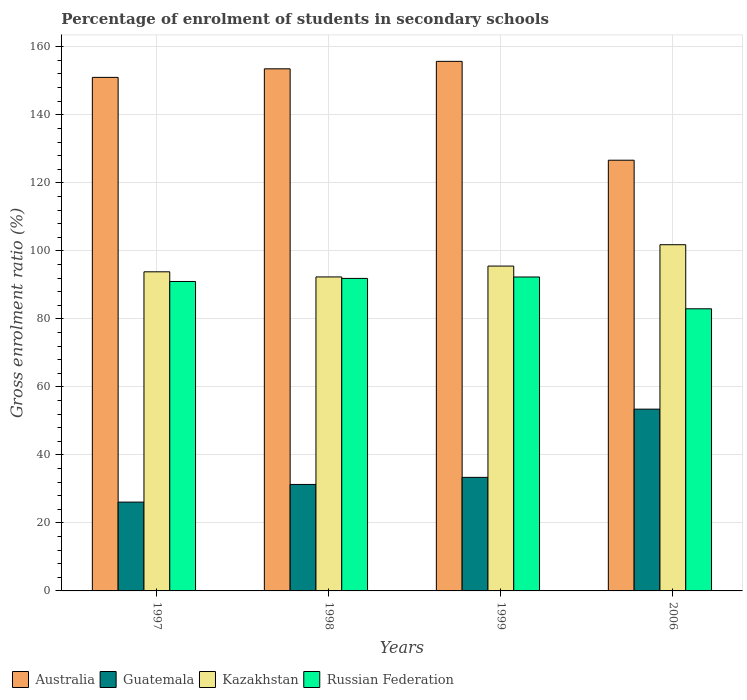Are the number of bars per tick equal to the number of legend labels?
Provide a short and direct response. Yes. Are the number of bars on each tick of the X-axis equal?
Keep it short and to the point. Yes. In how many cases, is the number of bars for a given year not equal to the number of legend labels?
Provide a succinct answer. 0. What is the percentage of students enrolled in secondary schools in Australia in 1997?
Offer a terse response. 151. Across all years, what is the maximum percentage of students enrolled in secondary schools in Kazakhstan?
Offer a terse response. 101.8. Across all years, what is the minimum percentage of students enrolled in secondary schools in Australia?
Your answer should be compact. 126.65. In which year was the percentage of students enrolled in secondary schools in Kazakhstan maximum?
Keep it short and to the point. 2006. What is the total percentage of students enrolled in secondary schools in Kazakhstan in the graph?
Provide a succinct answer. 383.48. What is the difference between the percentage of students enrolled in secondary schools in Guatemala in 1997 and that in 1999?
Make the answer very short. -7.27. What is the difference between the percentage of students enrolled in secondary schools in Australia in 1998 and the percentage of students enrolled in secondary schools in Kazakhstan in 2006?
Make the answer very short. 51.72. What is the average percentage of students enrolled in secondary schools in Kazakhstan per year?
Provide a succinct answer. 95.87. In the year 1998, what is the difference between the percentage of students enrolled in secondary schools in Kazakhstan and percentage of students enrolled in secondary schools in Russian Federation?
Offer a terse response. 0.44. In how many years, is the percentage of students enrolled in secondary schools in Kazakhstan greater than 136 %?
Make the answer very short. 0. What is the ratio of the percentage of students enrolled in secondary schools in Russian Federation in 1997 to that in 2006?
Your response must be concise. 1.1. Is the percentage of students enrolled in secondary schools in Kazakhstan in 1998 less than that in 1999?
Your answer should be very brief. Yes. Is the difference between the percentage of students enrolled in secondary schools in Kazakhstan in 1997 and 1998 greater than the difference between the percentage of students enrolled in secondary schools in Russian Federation in 1997 and 1998?
Ensure brevity in your answer.  Yes. What is the difference between the highest and the second highest percentage of students enrolled in secondary schools in Russian Federation?
Provide a succinct answer. 0.42. What is the difference between the highest and the lowest percentage of students enrolled in secondary schools in Kazakhstan?
Keep it short and to the point. 9.47. In how many years, is the percentage of students enrolled in secondary schools in Russian Federation greater than the average percentage of students enrolled in secondary schools in Russian Federation taken over all years?
Your response must be concise. 3. Is it the case that in every year, the sum of the percentage of students enrolled in secondary schools in Australia and percentage of students enrolled in secondary schools in Guatemala is greater than the sum of percentage of students enrolled in secondary schools in Kazakhstan and percentage of students enrolled in secondary schools in Russian Federation?
Ensure brevity in your answer.  No. What does the 2nd bar from the left in 2006 represents?
Provide a succinct answer. Guatemala. What does the 4th bar from the right in 1997 represents?
Give a very brief answer. Australia. How many years are there in the graph?
Give a very brief answer. 4. Are the values on the major ticks of Y-axis written in scientific E-notation?
Provide a short and direct response. No. Where does the legend appear in the graph?
Make the answer very short. Bottom left. How many legend labels are there?
Ensure brevity in your answer.  4. What is the title of the graph?
Your answer should be compact. Percentage of enrolment of students in secondary schools. Does "South Africa" appear as one of the legend labels in the graph?
Make the answer very short. No. What is the label or title of the Y-axis?
Offer a very short reply. Gross enrolment ratio (%). What is the Gross enrolment ratio (%) in Australia in 1997?
Offer a terse response. 151. What is the Gross enrolment ratio (%) in Guatemala in 1997?
Your answer should be compact. 26.12. What is the Gross enrolment ratio (%) in Kazakhstan in 1997?
Your answer should be very brief. 93.83. What is the Gross enrolment ratio (%) in Russian Federation in 1997?
Offer a terse response. 90.99. What is the Gross enrolment ratio (%) of Australia in 1998?
Keep it short and to the point. 153.52. What is the Gross enrolment ratio (%) of Guatemala in 1998?
Give a very brief answer. 31.31. What is the Gross enrolment ratio (%) of Kazakhstan in 1998?
Make the answer very short. 92.33. What is the Gross enrolment ratio (%) of Russian Federation in 1998?
Offer a terse response. 91.89. What is the Gross enrolment ratio (%) of Australia in 1999?
Offer a terse response. 155.71. What is the Gross enrolment ratio (%) of Guatemala in 1999?
Ensure brevity in your answer.  33.39. What is the Gross enrolment ratio (%) in Kazakhstan in 1999?
Offer a very short reply. 95.52. What is the Gross enrolment ratio (%) in Russian Federation in 1999?
Provide a succinct answer. 92.31. What is the Gross enrolment ratio (%) in Australia in 2006?
Your answer should be very brief. 126.65. What is the Gross enrolment ratio (%) of Guatemala in 2006?
Your answer should be compact. 53.45. What is the Gross enrolment ratio (%) of Kazakhstan in 2006?
Give a very brief answer. 101.8. What is the Gross enrolment ratio (%) in Russian Federation in 2006?
Provide a succinct answer. 82.96. Across all years, what is the maximum Gross enrolment ratio (%) of Australia?
Your answer should be compact. 155.71. Across all years, what is the maximum Gross enrolment ratio (%) in Guatemala?
Provide a succinct answer. 53.45. Across all years, what is the maximum Gross enrolment ratio (%) in Kazakhstan?
Your response must be concise. 101.8. Across all years, what is the maximum Gross enrolment ratio (%) of Russian Federation?
Provide a short and direct response. 92.31. Across all years, what is the minimum Gross enrolment ratio (%) in Australia?
Provide a succinct answer. 126.65. Across all years, what is the minimum Gross enrolment ratio (%) in Guatemala?
Give a very brief answer. 26.12. Across all years, what is the minimum Gross enrolment ratio (%) of Kazakhstan?
Make the answer very short. 92.33. Across all years, what is the minimum Gross enrolment ratio (%) of Russian Federation?
Your answer should be compact. 82.96. What is the total Gross enrolment ratio (%) in Australia in the graph?
Your answer should be very brief. 586.88. What is the total Gross enrolment ratio (%) in Guatemala in the graph?
Your answer should be very brief. 144.27. What is the total Gross enrolment ratio (%) in Kazakhstan in the graph?
Your answer should be compact. 383.48. What is the total Gross enrolment ratio (%) of Russian Federation in the graph?
Keep it short and to the point. 358.15. What is the difference between the Gross enrolment ratio (%) of Australia in 1997 and that in 1998?
Ensure brevity in your answer.  -2.52. What is the difference between the Gross enrolment ratio (%) in Guatemala in 1997 and that in 1998?
Your response must be concise. -5.19. What is the difference between the Gross enrolment ratio (%) of Kazakhstan in 1997 and that in 1998?
Your answer should be compact. 1.51. What is the difference between the Gross enrolment ratio (%) of Russian Federation in 1997 and that in 1998?
Offer a terse response. -0.9. What is the difference between the Gross enrolment ratio (%) of Australia in 1997 and that in 1999?
Give a very brief answer. -4.71. What is the difference between the Gross enrolment ratio (%) of Guatemala in 1997 and that in 1999?
Your answer should be compact. -7.27. What is the difference between the Gross enrolment ratio (%) in Kazakhstan in 1997 and that in 1999?
Provide a short and direct response. -1.69. What is the difference between the Gross enrolment ratio (%) in Russian Federation in 1997 and that in 1999?
Make the answer very short. -1.32. What is the difference between the Gross enrolment ratio (%) of Australia in 1997 and that in 2006?
Offer a very short reply. 24.35. What is the difference between the Gross enrolment ratio (%) of Guatemala in 1997 and that in 2006?
Offer a very short reply. -27.33. What is the difference between the Gross enrolment ratio (%) of Kazakhstan in 1997 and that in 2006?
Offer a very short reply. -7.96. What is the difference between the Gross enrolment ratio (%) of Russian Federation in 1997 and that in 2006?
Make the answer very short. 8.03. What is the difference between the Gross enrolment ratio (%) of Australia in 1998 and that in 1999?
Give a very brief answer. -2.19. What is the difference between the Gross enrolment ratio (%) of Guatemala in 1998 and that in 1999?
Your answer should be very brief. -2.08. What is the difference between the Gross enrolment ratio (%) in Kazakhstan in 1998 and that in 1999?
Your response must be concise. -3.19. What is the difference between the Gross enrolment ratio (%) of Russian Federation in 1998 and that in 1999?
Your answer should be very brief. -0.42. What is the difference between the Gross enrolment ratio (%) in Australia in 1998 and that in 2006?
Provide a short and direct response. 26.87. What is the difference between the Gross enrolment ratio (%) of Guatemala in 1998 and that in 2006?
Your response must be concise. -22.14. What is the difference between the Gross enrolment ratio (%) in Kazakhstan in 1998 and that in 2006?
Your answer should be very brief. -9.47. What is the difference between the Gross enrolment ratio (%) of Russian Federation in 1998 and that in 2006?
Your answer should be compact. 8.93. What is the difference between the Gross enrolment ratio (%) of Australia in 1999 and that in 2006?
Your response must be concise. 29.07. What is the difference between the Gross enrolment ratio (%) of Guatemala in 1999 and that in 2006?
Make the answer very short. -20.06. What is the difference between the Gross enrolment ratio (%) in Kazakhstan in 1999 and that in 2006?
Offer a very short reply. -6.28. What is the difference between the Gross enrolment ratio (%) in Russian Federation in 1999 and that in 2006?
Ensure brevity in your answer.  9.35. What is the difference between the Gross enrolment ratio (%) in Australia in 1997 and the Gross enrolment ratio (%) in Guatemala in 1998?
Keep it short and to the point. 119.69. What is the difference between the Gross enrolment ratio (%) in Australia in 1997 and the Gross enrolment ratio (%) in Kazakhstan in 1998?
Provide a short and direct response. 58.67. What is the difference between the Gross enrolment ratio (%) of Australia in 1997 and the Gross enrolment ratio (%) of Russian Federation in 1998?
Your response must be concise. 59.11. What is the difference between the Gross enrolment ratio (%) in Guatemala in 1997 and the Gross enrolment ratio (%) in Kazakhstan in 1998?
Offer a very short reply. -66.21. What is the difference between the Gross enrolment ratio (%) of Guatemala in 1997 and the Gross enrolment ratio (%) of Russian Federation in 1998?
Your answer should be very brief. -65.77. What is the difference between the Gross enrolment ratio (%) in Kazakhstan in 1997 and the Gross enrolment ratio (%) in Russian Federation in 1998?
Keep it short and to the point. 1.94. What is the difference between the Gross enrolment ratio (%) in Australia in 1997 and the Gross enrolment ratio (%) in Guatemala in 1999?
Ensure brevity in your answer.  117.61. What is the difference between the Gross enrolment ratio (%) of Australia in 1997 and the Gross enrolment ratio (%) of Kazakhstan in 1999?
Give a very brief answer. 55.48. What is the difference between the Gross enrolment ratio (%) of Australia in 1997 and the Gross enrolment ratio (%) of Russian Federation in 1999?
Your answer should be compact. 58.69. What is the difference between the Gross enrolment ratio (%) in Guatemala in 1997 and the Gross enrolment ratio (%) in Kazakhstan in 1999?
Make the answer very short. -69.4. What is the difference between the Gross enrolment ratio (%) in Guatemala in 1997 and the Gross enrolment ratio (%) in Russian Federation in 1999?
Give a very brief answer. -66.19. What is the difference between the Gross enrolment ratio (%) of Kazakhstan in 1997 and the Gross enrolment ratio (%) of Russian Federation in 1999?
Provide a short and direct response. 1.53. What is the difference between the Gross enrolment ratio (%) of Australia in 1997 and the Gross enrolment ratio (%) of Guatemala in 2006?
Ensure brevity in your answer.  97.55. What is the difference between the Gross enrolment ratio (%) in Australia in 1997 and the Gross enrolment ratio (%) in Kazakhstan in 2006?
Provide a succinct answer. 49.2. What is the difference between the Gross enrolment ratio (%) of Australia in 1997 and the Gross enrolment ratio (%) of Russian Federation in 2006?
Ensure brevity in your answer.  68.04. What is the difference between the Gross enrolment ratio (%) in Guatemala in 1997 and the Gross enrolment ratio (%) in Kazakhstan in 2006?
Your answer should be compact. -75.68. What is the difference between the Gross enrolment ratio (%) of Guatemala in 1997 and the Gross enrolment ratio (%) of Russian Federation in 2006?
Provide a short and direct response. -56.84. What is the difference between the Gross enrolment ratio (%) in Kazakhstan in 1997 and the Gross enrolment ratio (%) in Russian Federation in 2006?
Make the answer very short. 10.87. What is the difference between the Gross enrolment ratio (%) in Australia in 1998 and the Gross enrolment ratio (%) in Guatemala in 1999?
Your response must be concise. 120.13. What is the difference between the Gross enrolment ratio (%) of Australia in 1998 and the Gross enrolment ratio (%) of Kazakhstan in 1999?
Ensure brevity in your answer.  58. What is the difference between the Gross enrolment ratio (%) of Australia in 1998 and the Gross enrolment ratio (%) of Russian Federation in 1999?
Keep it short and to the point. 61.21. What is the difference between the Gross enrolment ratio (%) in Guatemala in 1998 and the Gross enrolment ratio (%) in Kazakhstan in 1999?
Offer a terse response. -64.21. What is the difference between the Gross enrolment ratio (%) of Guatemala in 1998 and the Gross enrolment ratio (%) of Russian Federation in 1999?
Your response must be concise. -61. What is the difference between the Gross enrolment ratio (%) of Kazakhstan in 1998 and the Gross enrolment ratio (%) of Russian Federation in 1999?
Ensure brevity in your answer.  0.02. What is the difference between the Gross enrolment ratio (%) of Australia in 1998 and the Gross enrolment ratio (%) of Guatemala in 2006?
Your response must be concise. 100.07. What is the difference between the Gross enrolment ratio (%) in Australia in 1998 and the Gross enrolment ratio (%) in Kazakhstan in 2006?
Provide a short and direct response. 51.72. What is the difference between the Gross enrolment ratio (%) of Australia in 1998 and the Gross enrolment ratio (%) of Russian Federation in 2006?
Your answer should be compact. 70.56. What is the difference between the Gross enrolment ratio (%) in Guatemala in 1998 and the Gross enrolment ratio (%) in Kazakhstan in 2006?
Provide a short and direct response. -70.49. What is the difference between the Gross enrolment ratio (%) in Guatemala in 1998 and the Gross enrolment ratio (%) in Russian Federation in 2006?
Ensure brevity in your answer.  -51.65. What is the difference between the Gross enrolment ratio (%) in Kazakhstan in 1998 and the Gross enrolment ratio (%) in Russian Federation in 2006?
Your answer should be compact. 9.37. What is the difference between the Gross enrolment ratio (%) of Australia in 1999 and the Gross enrolment ratio (%) of Guatemala in 2006?
Offer a very short reply. 102.27. What is the difference between the Gross enrolment ratio (%) in Australia in 1999 and the Gross enrolment ratio (%) in Kazakhstan in 2006?
Provide a succinct answer. 53.92. What is the difference between the Gross enrolment ratio (%) of Australia in 1999 and the Gross enrolment ratio (%) of Russian Federation in 2006?
Ensure brevity in your answer.  72.75. What is the difference between the Gross enrolment ratio (%) in Guatemala in 1999 and the Gross enrolment ratio (%) in Kazakhstan in 2006?
Keep it short and to the point. -68.41. What is the difference between the Gross enrolment ratio (%) of Guatemala in 1999 and the Gross enrolment ratio (%) of Russian Federation in 2006?
Your answer should be compact. -49.57. What is the difference between the Gross enrolment ratio (%) in Kazakhstan in 1999 and the Gross enrolment ratio (%) in Russian Federation in 2006?
Offer a very short reply. 12.56. What is the average Gross enrolment ratio (%) of Australia per year?
Offer a terse response. 146.72. What is the average Gross enrolment ratio (%) of Guatemala per year?
Your answer should be compact. 36.07. What is the average Gross enrolment ratio (%) in Kazakhstan per year?
Provide a short and direct response. 95.87. What is the average Gross enrolment ratio (%) in Russian Federation per year?
Give a very brief answer. 89.54. In the year 1997, what is the difference between the Gross enrolment ratio (%) of Australia and Gross enrolment ratio (%) of Guatemala?
Provide a short and direct response. 124.88. In the year 1997, what is the difference between the Gross enrolment ratio (%) of Australia and Gross enrolment ratio (%) of Kazakhstan?
Keep it short and to the point. 57.17. In the year 1997, what is the difference between the Gross enrolment ratio (%) in Australia and Gross enrolment ratio (%) in Russian Federation?
Make the answer very short. 60.01. In the year 1997, what is the difference between the Gross enrolment ratio (%) of Guatemala and Gross enrolment ratio (%) of Kazakhstan?
Offer a very short reply. -67.72. In the year 1997, what is the difference between the Gross enrolment ratio (%) in Guatemala and Gross enrolment ratio (%) in Russian Federation?
Provide a succinct answer. -64.87. In the year 1997, what is the difference between the Gross enrolment ratio (%) of Kazakhstan and Gross enrolment ratio (%) of Russian Federation?
Keep it short and to the point. 2.85. In the year 1998, what is the difference between the Gross enrolment ratio (%) of Australia and Gross enrolment ratio (%) of Guatemala?
Your answer should be compact. 122.21. In the year 1998, what is the difference between the Gross enrolment ratio (%) in Australia and Gross enrolment ratio (%) in Kazakhstan?
Give a very brief answer. 61.19. In the year 1998, what is the difference between the Gross enrolment ratio (%) in Australia and Gross enrolment ratio (%) in Russian Federation?
Your answer should be very brief. 61.63. In the year 1998, what is the difference between the Gross enrolment ratio (%) of Guatemala and Gross enrolment ratio (%) of Kazakhstan?
Your answer should be very brief. -61.02. In the year 1998, what is the difference between the Gross enrolment ratio (%) in Guatemala and Gross enrolment ratio (%) in Russian Federation?
Your answer should be compact. -60.58. In the year 1998, what is the difference between the Gross enrolment ratio (%) of Kazakhstan and Gross enrolment ratio (%) of Russian Federation?
Your answer should be very brief. 0.44. In the year 1999, what is the difference between the Gross enrolment ratio (%) of Australia and Gross enrolment ratio (%) of Guatemala?
Your answer should be very brief. 122.32. In the year 1999, what is the difference between the Gross enrolment ratio (%) in Australia and Gross enrolment ratio (%) in Kazakhstan?
Offer a very short reply. 60.2. In the year 1999, what is the difference between the Gross enrolment ratio (%) in Australia and Gross enrolment ratio (%) in Russian Federation?
Provide a short and direct response. 63.41. In the year 1999, what is the difference between the Gross enrolment ratio (%) in Guatemala and Gross enrolment ratio (%) in Kazakhstan?
Offer a terse response. -62.13. In the year 1999, what is the difference between the Gross enrolment ratio (%) of Guatemala and Gross enrolment ratio (%) of Russian Federation?
Give a very brief answer. -58.92. In the year 1999, what is the difference between the Gross enrolment ratio (%) in Kazakhstan and Gross enrolment ratio (%) in Russian Federation?
Give a very brief answer. 3.21. In the year 2006, what is the difference between the Gross enrolment ratio (%) of Australia and Gross enrolment ratio (%) of Guatemala?
Offer a very short reply. 73.2. In the year 2006, what is the difference between the Gross enrolment ratio (%) in Australia and Gross enrolment ratio (%) in Kazakhstan?
Your answer should be compact. 24.85. In the year 2006, what is the difference between the Gross enrolment ratio (%) of Australia and Gross enrolment ratio (%) of Russian Federation?
Your response must be concise. 43.69. In the year 2006, what is the difference between the Gross enrolment ratio (%) in Guatemala and Gross enrolment ratio (%) in Kazakhstan?
Ensure brevity in your answer.  -48.35. In the year 2006, what is the difference between the Gross enrolment ratio (%) of Guatemala and Gross enrolment ratio (%) of Russian Federation?
Your answer should be compact. -29.51. In the year 2006, what is the difference between the Gross enrolment ratio (%) in Kazakhstan and Gross enrolment ratio (%) in Russian Federation?
Offer a very short reply. 18.84. What is the ratio of the Gross enrolment ratio (%) in Australia in 1997 to that in 1998?
Make the answer very short. 0.98. What is the ratio of the Gross enrolment ratio (%) of Guatemala in 1997 to that in 1998?
Your answer should be very brief. 0.83. What is the ratio of the Gross enrolment ratio (%) of Kazakhstan in 1997 to that in 1998?
Make the answer very short. 1.02. What is the ratio of the Gross enrolment ratio (%) in Russian Federation in 1997 to that in 1998?
Provide a short and direct response. 0.99. What is the ratio of the Gross enrolment ratio (%) of Australia in 1997 to that in 1999?
Ensure brevity in your answer.  0.97. What is the ratio of the Gross enrolment ratio (%) in Guatemala in 1997 to that in 1999?
Offer a terse response. 0.78. What is the ratio of the Gross enrolment ratio (%) of Kazakhstan in 1997 to that in 1999?
Your answer should be very brief. 0.98. What is the ratio of the Gross enrolment ratio (%) in Russian Federation in 1997 to that in 1999?
Keep it short and to the point. 0.99. What is the ratio of the Gross enrolment ratio (%) of Australia in 1997 to that in 2006?
Your answer should be compact. 1.19. What is the ratio of the Gross enrolment ratio (%) of Guatemala in 1997 to that in 2006?
Offer a very short reply. 0.49. What is the ratio of the Gross enrolment ratio (%) in Kazakhstan in 1997 to that in 2006?
Your answer should be compact. 0.92. What is the ratio of the Gross enrolment ratio (%) in Russian Federation in 1997 to that in 2006?
Ensure brevity in your answer.  1.1. What is the ratio of the Gross enrolment ratio (%) in Australia in 1998 to that in 1999?
Provide a short and direct response. 0.99. What is the ratio of the Gross enrolment ratio (%) in Guatemala in 1998 to that in 1999?
Your answer should be very brief. 0.94. What is the ratio of the Gross enrolment ratio (%) of Kazakhstan in 1998 to that in 1999?
Offer a terse response. 0.97. What is the ratio of the Gross enrolment ratio (%) of Australia in 1998 to that in 2006?
Provide a succinct answer. 1.21. What is the ratio of the Gross enrolment ratio (%) of Guatemala in 1998 to that in 2006?
Your answer should be very brief. 0.59. What is the ratio of the Gross enrolment ratio (%) in Kazakhstan in 1998 to that in 2006?
Give a very brief answer. 0.91. What is the ratio of the Gross enrolment ratio (%) of Russian Federation in 1998 to that in 2006?
Ensure brevity in your answer.  1.11. What is the ratio of the Gross enrolment ratio (%) in Australia in 1999 to that in 2006?
Offer a terse response. 1.23. What is the ratio of the Gross enrolment ratio (%) in Guatemala in 1999 to that in 2006?
Provide a short and direct response. 0.62. What is the ratio of the Gross enrolment ratio (%) of Kazakhstan in 1999 to that in 2006?
Your response must be concise. 0.94. What is the ratio of the Gross enrolment ratio (%) of Russian Federation in 1999 to that in 2006?
Give a very brief answer. 1.11. What is the difference between the highest and the second highest Gross enrolment ratio (%) in Australia?
Your response must be concise. 2.19. What is the difference between the highest and the second highest Gross enrolment ratio (%) in Guatemala?
Offer a terse response. 20.06. What is the difference between the highest and the second highest Gross enrolment ratio (%) of Kazakhstan?
Make the answer very short. 6.28. What is the difference between the highest and the second highest Gross enrolment ratio (%) in Russian Federation?
Your answer should be very brief. 0.42. What is the difference between the highest and the lowest Gross enrolment ratio (%) of Australia?
Provide a short and direct response. 29.07. What is the difference between the highest and the lowest Gross enrolment ratio (%) of Guatemala?
Provide a succinct answer. 27.33. What is the difference between the highest and the lowest Gross enrolment ratio (%) in Kazakhstan?
Offer a very short reply. 9.47. What is the difference between the highest and the lowest Gross enrolment ratio (%) in Russian Federation?
Provide a short and direct response. 9.35. 